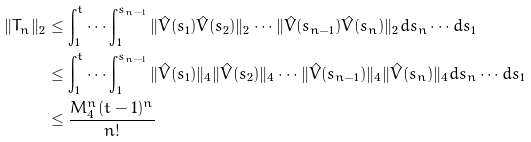Convert formula to latex. <formula><loc_0><loc_0><loc_500><loc_500>\| T _ { n } \| _ { 2 } & \leq \int _ { 1 } ^ { t } \cdots \int _ { 1 } ^ { s _ { n - 1 } } \| \hat { V } ( s _ { 1 } ) \hat { V } ( s _ { 2 } ) \| _ { 2 } \cdots \| \hat { V } ( s _ { n - 1 } ) \hat { V } ( s _ { n } ) \| _ { 2 } d s _ { n } \cdots d s _ { 1 } \\ & \leq \int _ { 1 } ^ { t } \cdots \int _ { 1 } ^ { s _ { n - 1 } } \| \hat { V } ( s _ { 1 } ) \| _ { 4 } \| \hat { V } ( s _ { 2 } ) \| _ { 4 } \cdots \| \hat { V } ( s _ { n - 1 } ) \| _ { 4 } \| \hat { V } ( s _ { n } ) \| _ { 4 } d s _ { n } \cdots d s _ { 1 } \\ & \leq \frac { M _ { 4 } ^ { n } ( t - 1 ) ^ { n } } { n ! }</formula> 